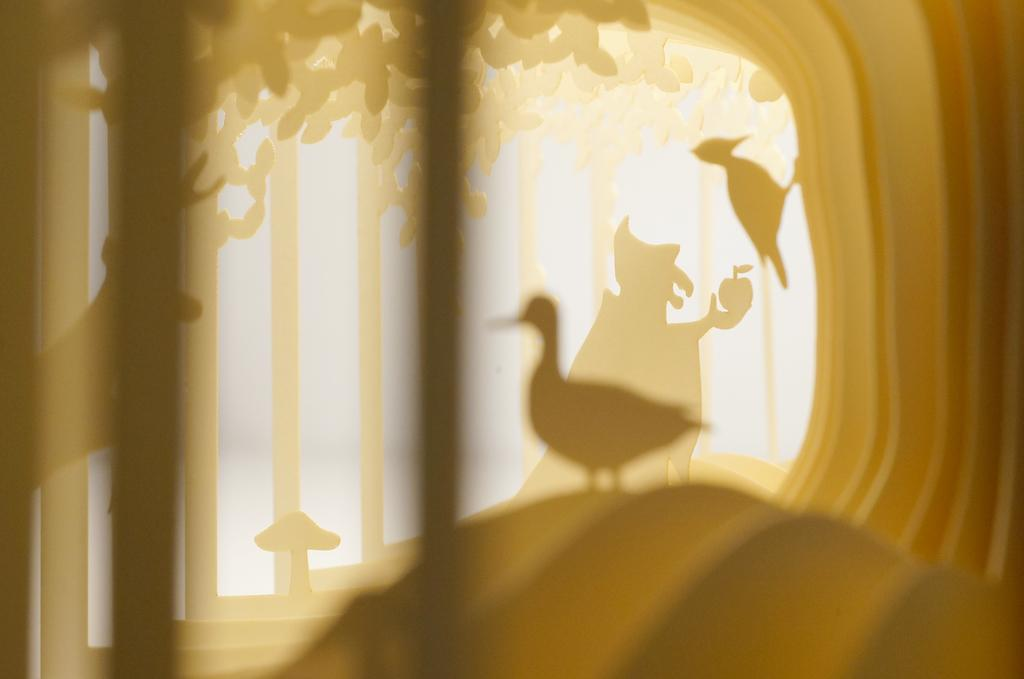What type of shadows can be seen in the image? There are shadows of birds and animals in the image. What architectural feature is present in the image? There are steps in the image. What type of vegetation is present in the image? Leaves are present in the image. How many wheels can be seen in the image? There are no wheels present in the image. What type of lift is used by the birds in the image? There are no birds or lifts present in the image. 